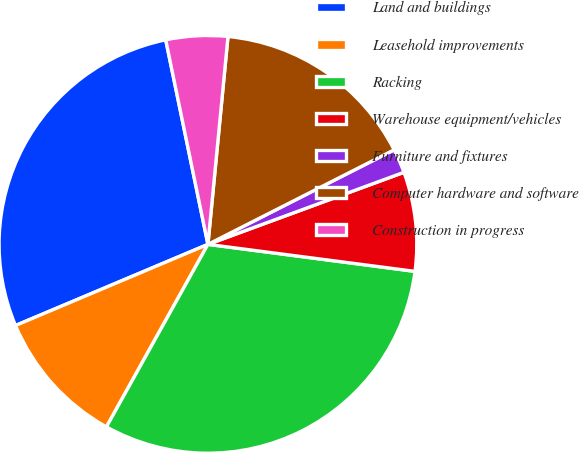Convert chart to OTSL. <chart><loc_0><loc_0><loc_500><loc_500><pie_chart><fcel>Land and buildings<fcel>Leasehold improvements<fcel>Racking<fcel>Warehouse equipment/vehicles<fcel>Furniture and fixtures<fcel>Computer hardware and software<fcel>Construction in progress<nl><fcel>28.11%<fcel>10.57%<fcel>31.01%<fcel>7.67%<fcel>1.87%<fcel>15.99%<fcel>4.77%<nl></chart> 